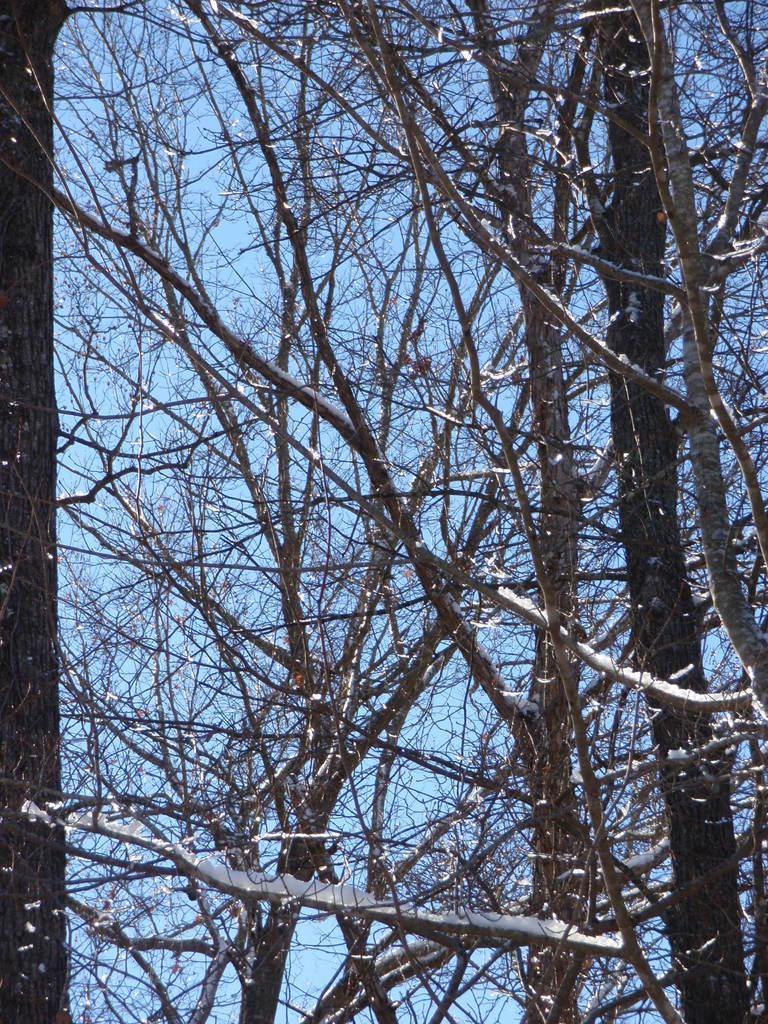Can you describe this image briefly? In this picture we can see few trees. 